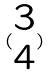Convert formula to latex. <formula><loc_0><loc_0><loc_500><loc_500>( \begin{matrix} 3 \\ 4 \end{matrix} )</formula> 